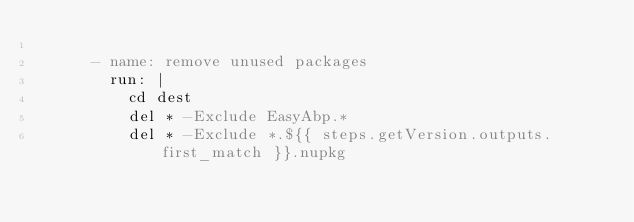Convert code to text. <code><loc_0><loc_0><loc_500><loc_500><_YAML_>
      - name: remove unused packages
        run: |
          cd dest
          del * -Exclude EasyAbp.*
          del * -Exclude *.${{ steps.getVersion.outputs.first_match }}.nupkg</code> 